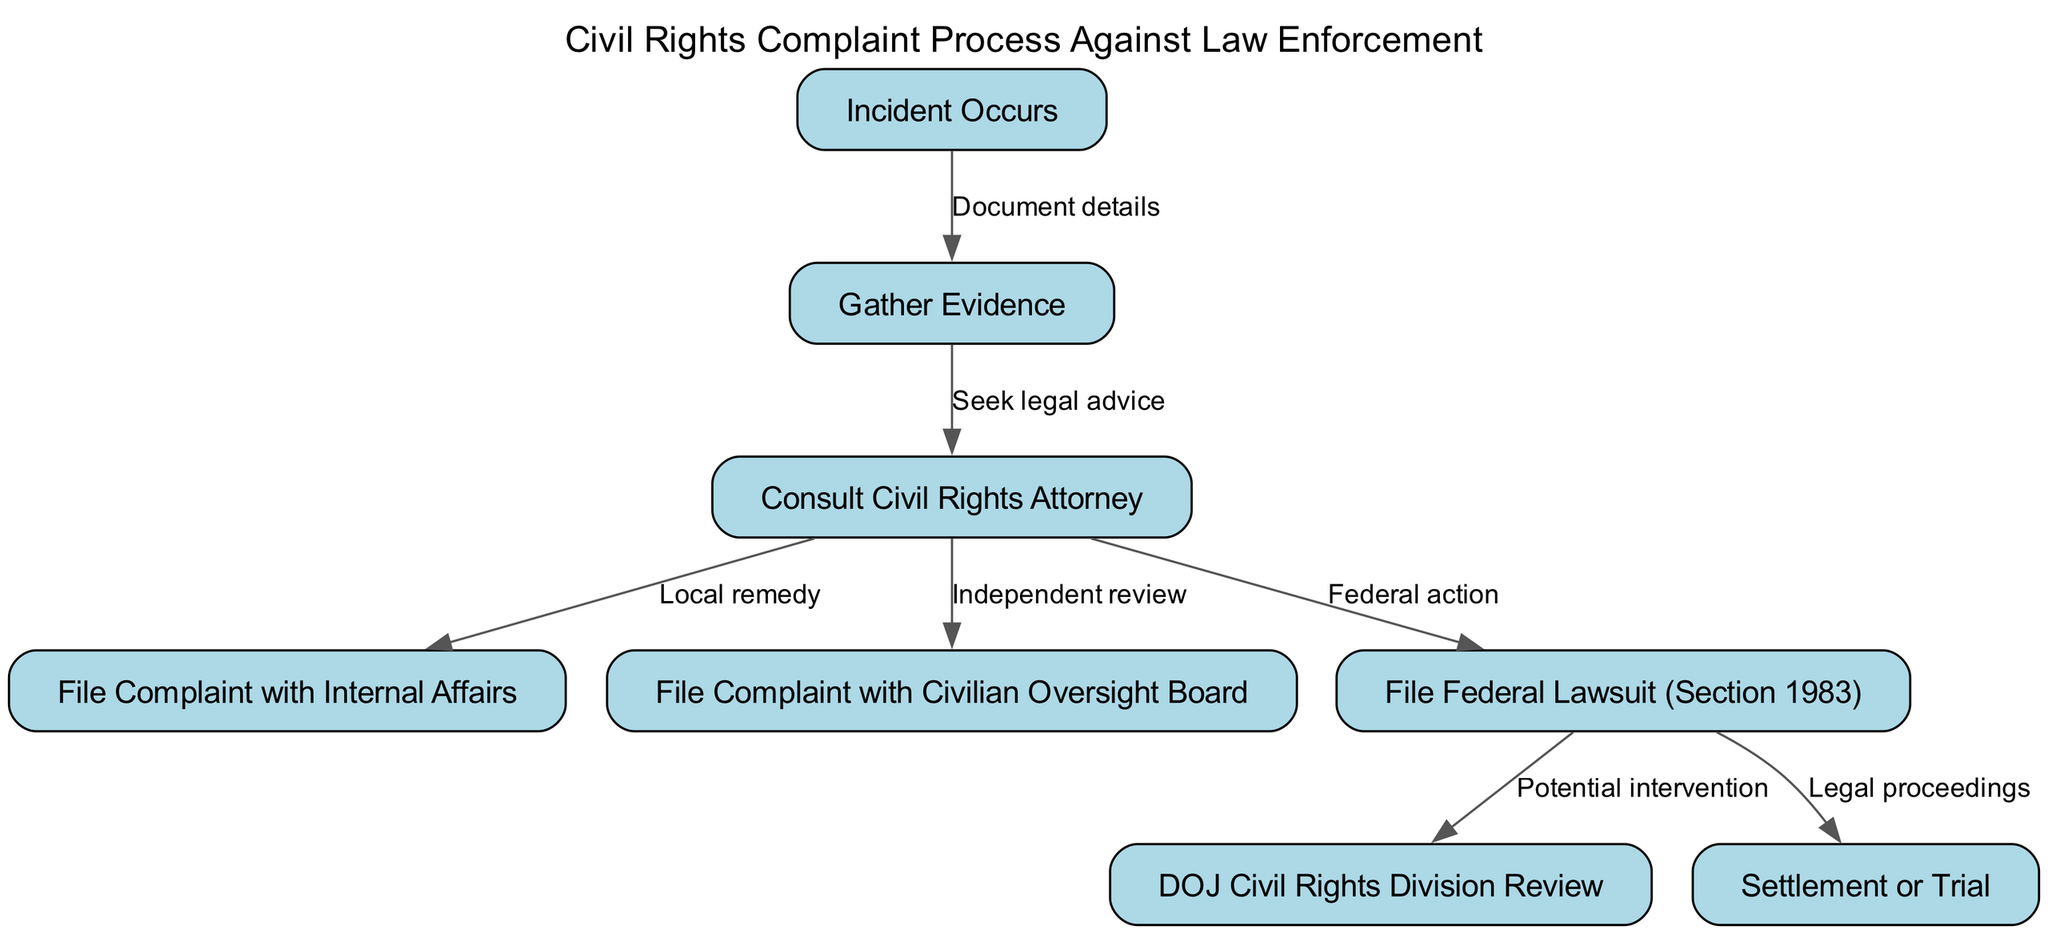What is the first step in the process? The first step in the flowchart is labeled "Incident Occurs." This is the starting point of the complaint process.
Answer: Incident Occurs How many nodes are present in the diagram? The diagram includes eight distinct nodes that represent different steps in the process of filing a complaint.
Answer: Eight What is the relationship between "Gather Evidence" and "Consult Civil Rights Attorney"? The directed edge from "Gather Evidence" to "Consult Civil Rights Attorney" is labeled "Seek legal advice," indicating that after gathering evidence, the next logical step is to seek legal advice.
Answer: Seek legal advice Which complaint filing options are available after consulting an attorney? After consulting an attorney, there are three options: filing a complaint with Internal Affairs, filing a complaint with the Civilian Oversight Board, or filing a federal lawsuit under Section 1983.
Answer: Three options: Internal Affairs, Civilian Oversight Board, Section 1983 What follow-up occurs if a Federal Lawsuit is filed? If a Federal Lawsuit (Section 1983) is filed, it can lead to a Department of Justice Civil Rights Division Review or lead directly to a Settlement or Trial as indicated in the subsequent nodes.
Answer: Review or Trial How many possible outcomes are there after filing a Federal Lawsuit? After filing a Federal Lawsuit, there are two possible outcomes indicated in the flowchart: a Settlement or Trial.
Answer: Two outcomes What is the purpose of filing a complaint with the Civilian Oversight Board? The purpose of filing a complaint with the Civilian Oversight Board, as indicated in the diagram, is to seek an independent review of the incident involving law enforcement.
Answer: Independent review What does the edge from "File Federal Lawsuit" to "DOJ Civil Rights Division Review" indicate? The edge signifies that filing a Federal Lawsuit can lead to a review by the Department of Justice Civil Rights Division, which may provide intervention in systemic issues.
Answer: Potential intervention 